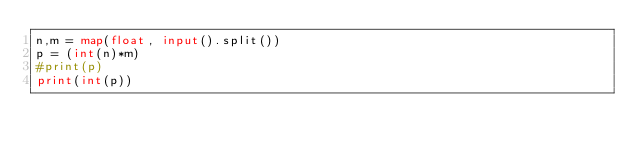<code> <loc_0><loc_0><loc_500><loc_500><_Python_>n,m = map(float, input().split())
p = (int(n)*m)
#print(p)
print(int(p))
</code> 